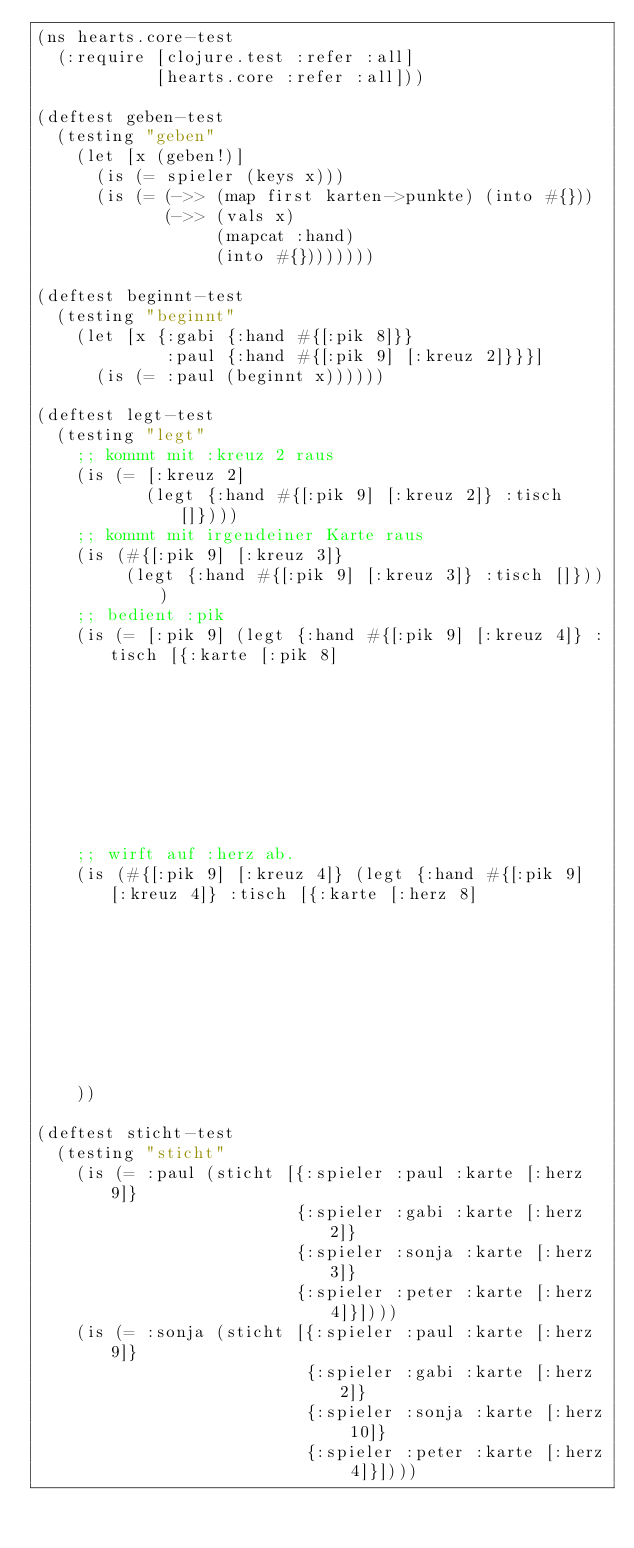<code> <loc_0><loc_0><loc_500><loc_500><_Clojure_>(ns hearts.core-test
  (:require [clojure.test :refer :all]
            [hearts.core :refer :all]))

(deftest geben-test
  (testing "geben"
    (let [x (geben!)]
      (is (= spieler (keys x)))
      (is (= (->> (map first karten->punkte) (into #{}))
             (->> (vals x)
                  (mapcat :hand)
                  (into #{})))))))

(deftest beginnt-test
  (testing "beginnt"
    (let [x {:gabi {:hand #{[:pik 8]}}
             :paul {:hand #{[:pik 9] [:kreuz 2]}}}]
      (is (= :paul (beginnt x))))))

(deftest legt-test
  (testing "legt"
    ;; kommt mit :kreuz 2 raus
    (is (= [:kreuz 2]
           (legt {:hand #{[:pik 9] [:kreuz 2]} :tisch []})))
    ;; kommt mit irgendeiner Karte raus
    (is (#{[:pik 9] [:kreuz 3]}
         (legt {:hand #{[:pik 9] [:kreuz 3]} :tisch []})))
    ;; bedient :pik
    (is (= [:pik 9] (legt {:hand #{[:pik 9] [:kreuz 4]} :tisch [{:karte [:pik 8]
                                                                 :spieler :paul}]})))
    ;; wirft auf :herz ab.
    (is (#{[:pik 9] [:kreuz 4]} (legt {:hand #{[:pik 9] [:kreuz 4]} :tisch [{:karte [:herz 8]
                                                                             :spieler :paul}]})))
    ))

(deftest sticht-test
  (testing "sticht"
    (is (= :paul (sticht [{:spieler :paul :karte [:herz 9]}
                          {:spieler :gabi :karte [:herz 2]}
                          {:spieler :sonja :karte [:herz 3]}
                          {:spieler :peter :karte [:herz 4]}])))
    (is (= :sonja (sticht [{:spieler :paul :karte [:herz 9]}
                           {:spieler :gabi :karte [:herz 2]}
                           {:spieler :sonja :karte [:herz 10]}
                           {:spieler :peter :karte [:herz 4]}])))</code> 